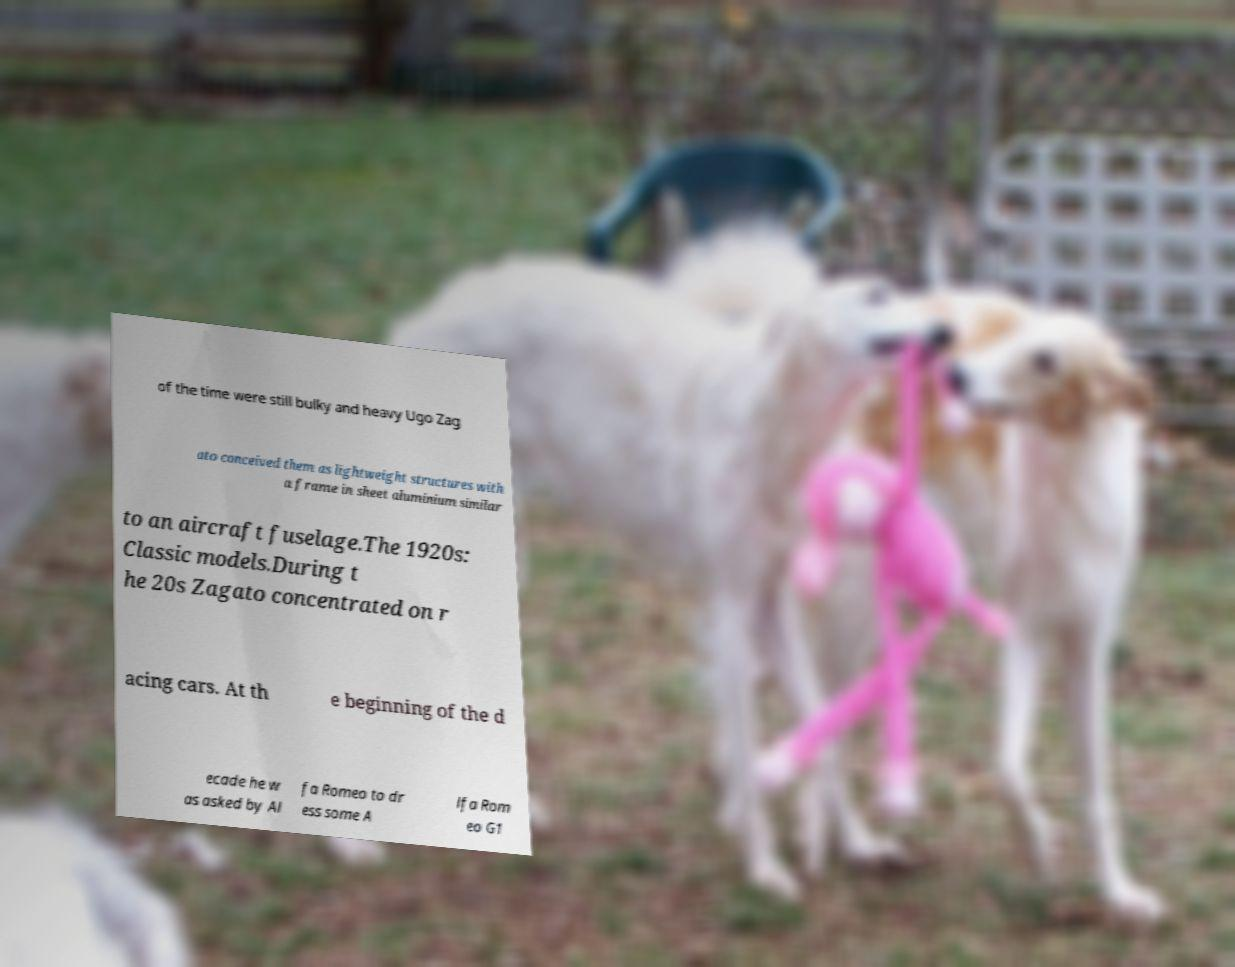Could you assist in decoding the text presented in this image and type it out clearly? of the time were still bulky and heavy Ugo Zag ato conceived them as lightweight structures with a frame in sheet aluminium similar to an aircraft fuselage.The 1920s: Classic models.During t he 20s Zagato concentrated on r acing cars. At th e beginning of the d ecade he w as asked by Al fa Romeo to dr ess some A lfa Rom eo G1 